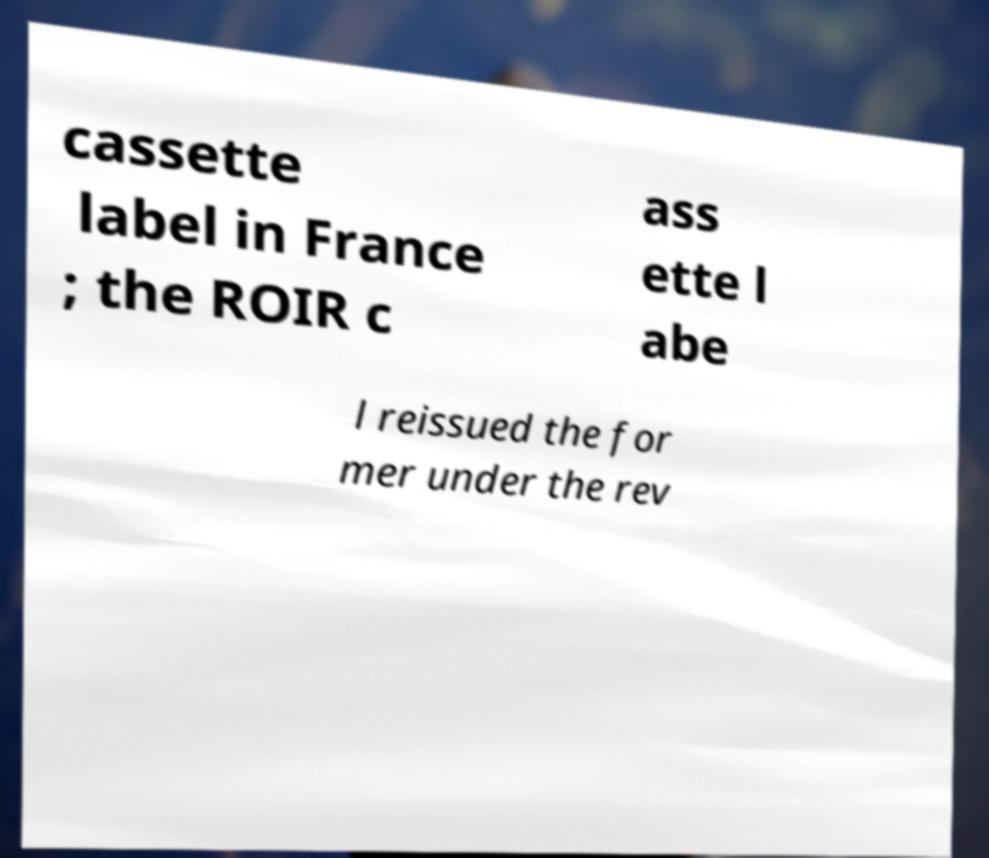Please read and relay the text visible in this image. What does it say? cassette label in France ; the ROIR c ass ette l abe l reissued the for mer under the rev 